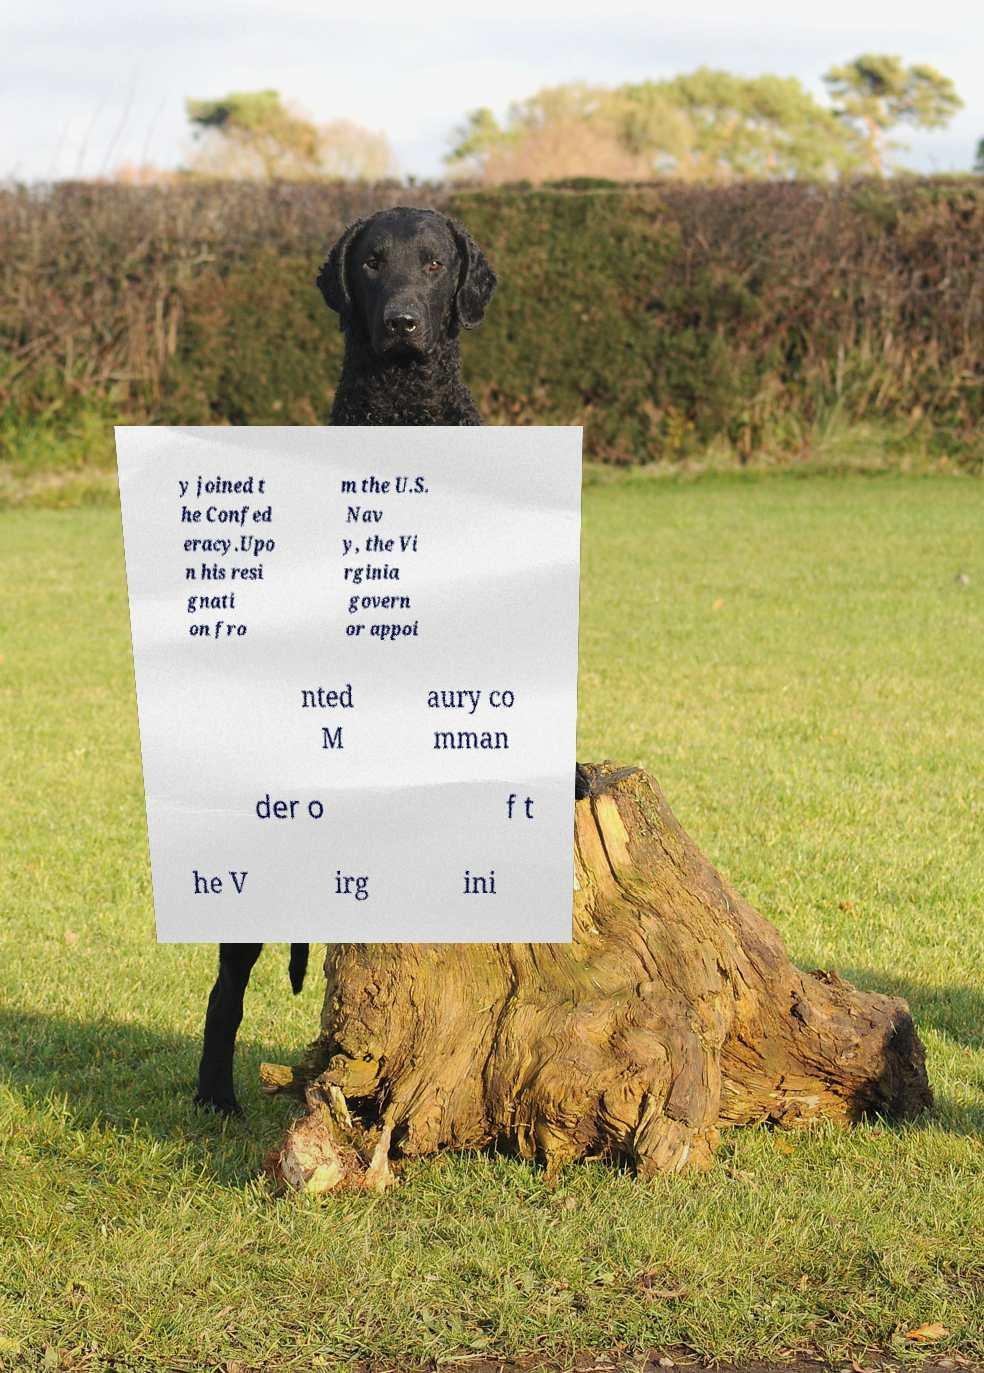Could you assist in decoding the text presented in this image and type it out clearly? y joined t he Confed eracy.Upo n his resi gnati on fro m the U.S. Nav y, the Vi rginia govern or appoi nted M aury co mman der o f t he V irg ini 